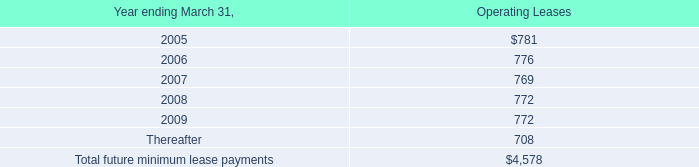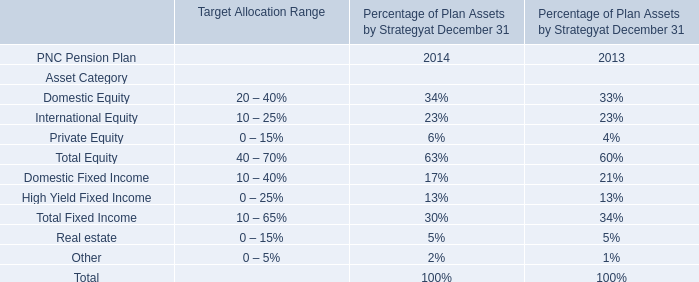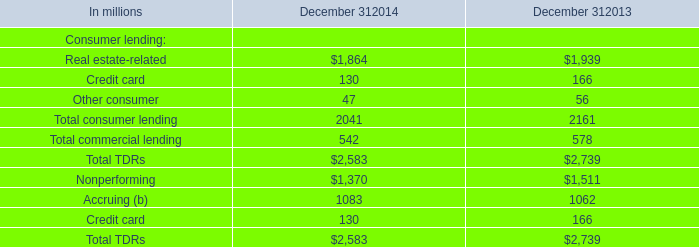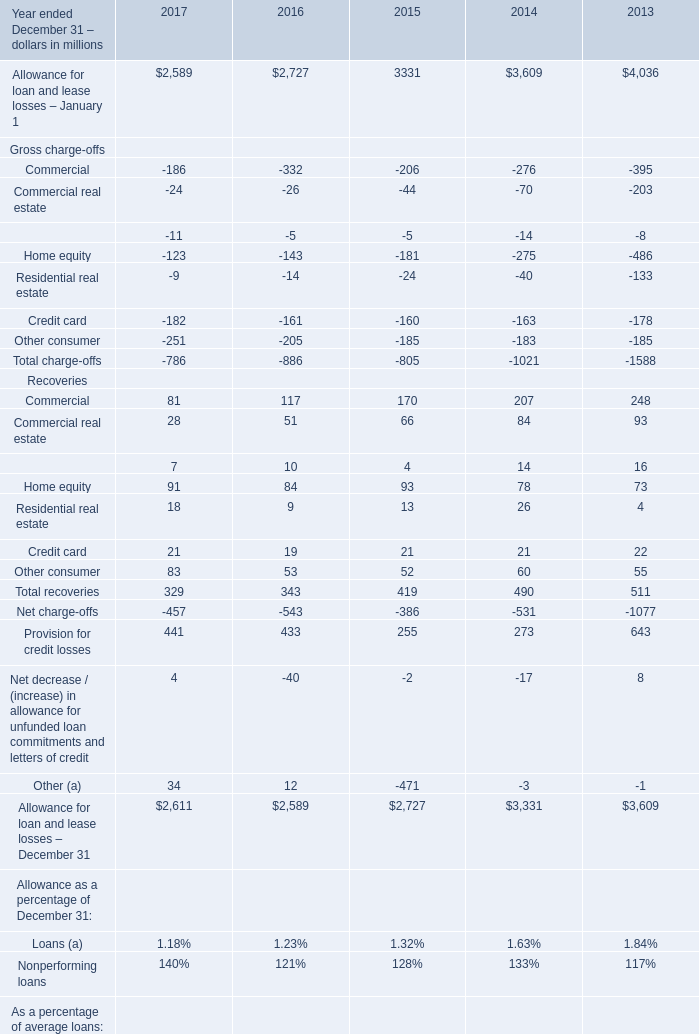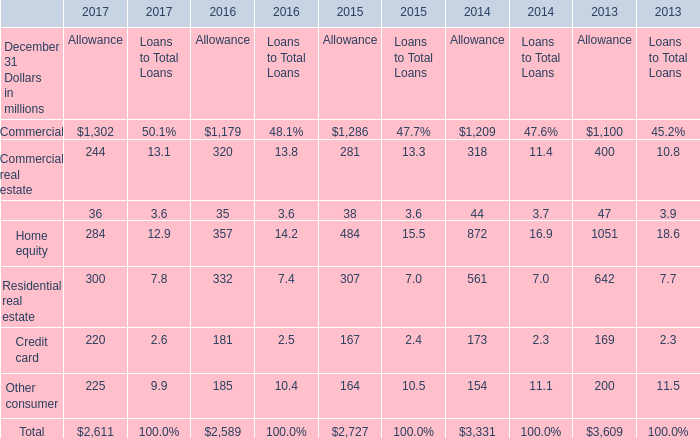Which year is Home equity for Recoveries the most? 
Answer: 2015. 